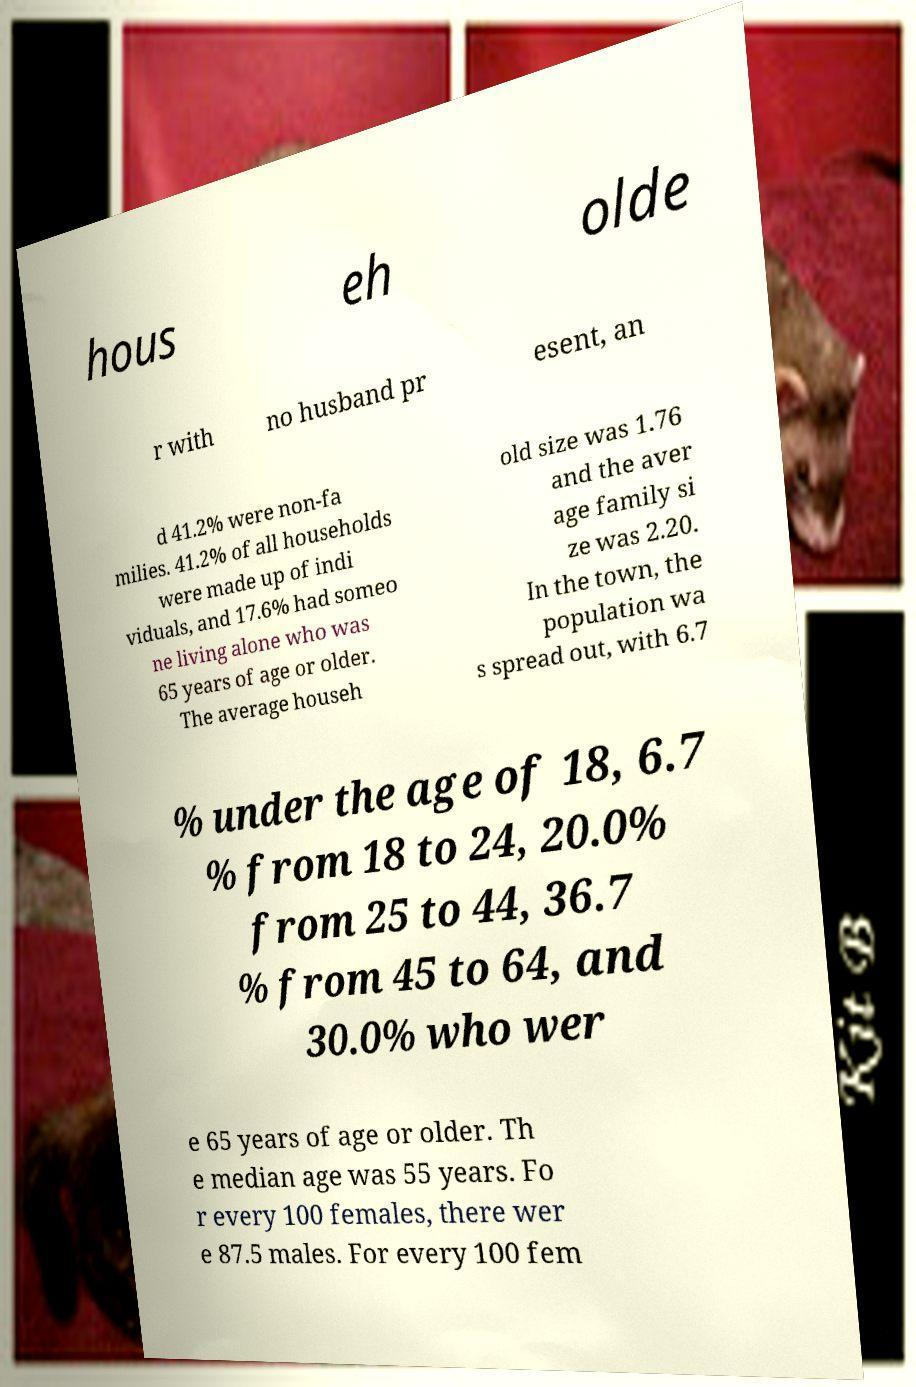Could you assist in decoding the text presented in this image and type it out clearly? hous eh olde r with no husband pr esent, an d 41.2% were non-fa milies. 41.2% of all households were made up of indi viduals, and 17.6% had someo ne living alone who was 65 years of age or older. The average househ old size was 1.76 and the aver age family si ze was 2.20. In the town, the population wa s spread out, with 6.7 % under the age of 18, 6.7 % from 18 to 24, 20.0% from 25 to 44, 36.7 % from 45 to 64, and 30.0% who wer e 65 years of age or older. Th e median age was 55 years. Fo r every 100 females, there wer e 87.5 males. For every 100 fem 